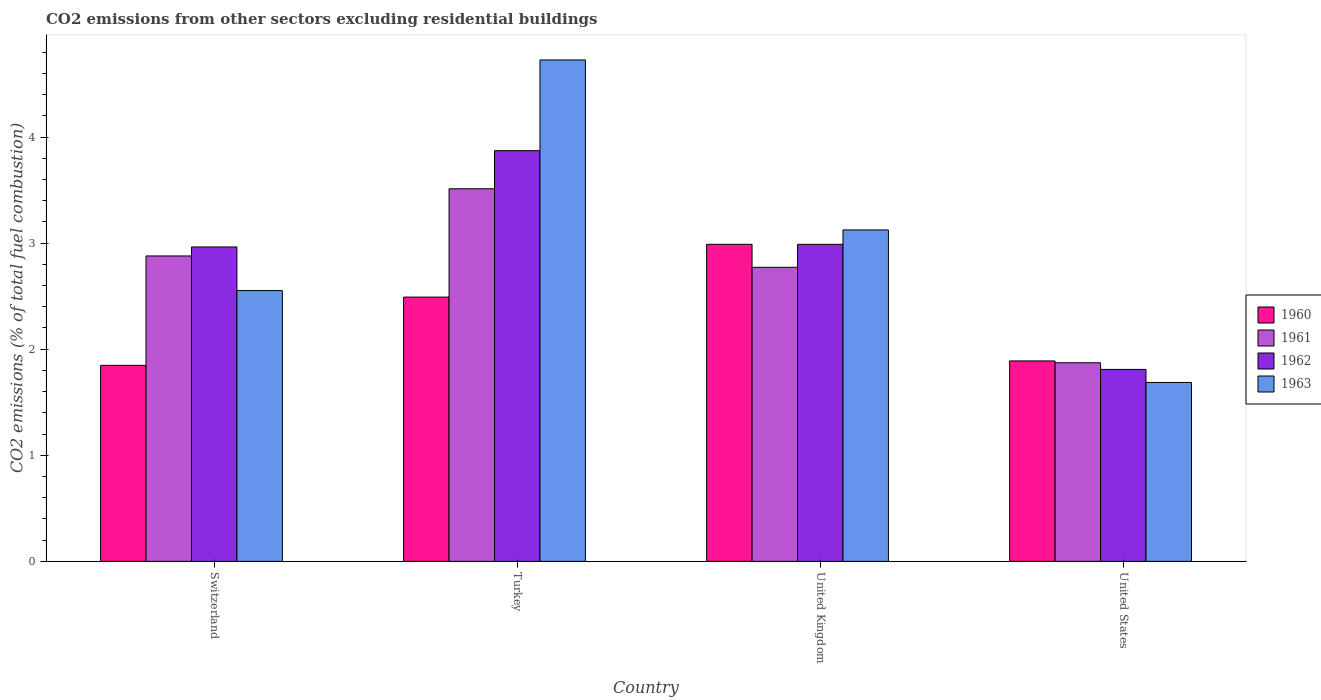How many different coloured bars are there?
Your response must be concise. 4. Are the number of bars on each tick of the X-axis equal?
Offer a very short reply. Yes. How many bars are there on the 2nd tick from the left?
Your response must be concise. 4. What is the label of the 3rd group of bars from the left?
Give a very brief answer. United Kingdom. What is the total CO2 emitted in 1963 in Switzerland?
Offer a terse response. 2.55. Across all countries, what is the maximum total CO2 emitted in 1962?
Keep it short and to the point. 3.87. Across all countries, what is the minimum total CO2 emitted in 1961?
Your answer should be compact. 1.87. What is the total total CO2 emitted in 1960 in the graph?
Provide a succinct answer. 9.22. What is the difference between the total CO2 emitted in 1962 in Switzerland and that in Turkey?
Keep it short and to the point. -0.91. What is the difference between the total CO2 emitted in 1963 in Turkey and the total CO2 emitted in 1960 in Switzerland?
Keep it short and to the point. 2.88. What is the average total CO2 emitted in 1960 per country?
Provide a succinct answer. 2.3. What is the difference between the total CO2 emitted of/in 1960 and total CO2 emitted of/in 1962 in United Kingdom?
Offer a terse response. -1.3986663769838259e-5. In how many countries, is the total CO2 emitted in 1963 greater than 3?
Provide a short and direct response. 2. What is the ratio of the total CO2 emitted in 1960 in Turkey to that in United Kingdom?
Your response must be concise. 0.83. Is the total CO2 emitted in 1961 in United Kingdom less than that in United States?
Offer a very short reply. No. What is the difference between the highest and the second highest total CO2 emitted in 1963?
Your answer should be compact. -0.57. What is the difference between the highest and the lowest total CO2 emitted in 1961?
Your answer should be very brief. 1.64. In how many countries, is the total CO2 emitted in 1961 greater than the average total CO2 emitted in 1961 taken over all countries?
Provide a short and direct response. 3. Is the sum of the total CO2 emitted in 1963 in Switzerland and United States greater than the maximum total CO2 emitted in 1960 across all countries?
Your answer should be compact. Yes. What does the 1st bar from the right in United States represents?
Your answer should be very brief. 1963. How many bars are there?
Provide a succinct answer. 16. Are all the bars in the graph horizontal?
Provide a succinct answer. No. Does the graph contain any zero values?
Provide a short and direct response. No. Does the graph contain grids?
Keep it short and to the point. No. How many legend labels are there?
Keep it short and to the point. 4. How are the legend labels stacked?
Your response must be concise. Vertical. What is the title of the graph?
Provide a succinct answer. CO2 emissions from other sectors excluding residential buildings. Does "1990" appear as one of the legend labels in the graph?
Your answer should be compact. No. What is the label or title of the Y-axis?
Offer a very short reply. CO2 emissions (% of total fuel combustion). What is the CO2 emissions (% of total fuel combustion) of 1960 in Switzerland?
Ensure brevity in your answer.  1.85. What is the CO2 emissions (% of total fuel combustion) in 1961 in Switzerland?
Offer a terse response. 2.88. What is the CO2 emissions (% of total fuel combustion) in 1962 in Switzerland?
Your response must be concise. 2.96. What is the CO2 emissions (% of total fuel combustion) in 1963 in Switzerland?
Your response must be concise. 2.55. What is the CO2 emissions (% of total fuel combustion) of 1960 in Turkey?
Give a very brief answer. 2.49. What is the CO2 emissions (% of total fuel combustion) of 1961 in Turkey?
Provide a short and direct response. 3.51. What is the CO2 emissions (% of total fuel combustion) of 1962 in Turkey?
Give a very brief answer. 3.87. What is the CO2 emissions (% of total fuel combustion) of 1963 in Turkey?
Keep it short and to the point. 4.73. What is the CO2 emissions (% of total fuel combustion) of 1960 in United Kingdom?
Keep it short and to the point. 2.99. What is the CO2 emissions (% of total fuel combustion) of 1961 in United Kingdom?
Offer a very short reply. 2.77. What is the CO2 emissions (% of total fuel combustion) of 1962 in United Kingdom?
Give a very brief answer. 2.99. What is the CO2 emissions (% of total fuel combustion) of 1963 in United Kingdom?
Make the answer very short. 3.12. What is the CO2 emissions (% of total fuel combustion) of 1960 in United States?
Provide a short and direct response. 1.89. What is the CO2 emissions (% of total fuel combustion) in 1961 in United States?
Your response must be concise. 1.87. What is the CO2 emissions (% of total fuel combustion) in 1962 in United States?
Your answer should be compact. 1.81. What is the CO2 emissions (% of total fuel combustion) in 1963 in United States?
Your response must be concise. 1.69. Across all countries, what is the maximum CO2 emissions (% of total fuel combustion) of 1960?
Give a very brief answer. 2.99. Across all countries, what is the maximum CO2 emissions (% of total fuel combustion) of 1961?
Offer a very short reply. 3.51. Across all countries, what is the maximum CO2 emissions (% of total fuel combustion) of 1962?
Your response must be concise. 3.87. Across all countries, what is the maximum CO2 emissions (% of total fuel combustion) in 1963?
Your answer should be very brief. 4.73. Across all countries, what is the minimum CO2 emissions (% of total fuel combustion) in 1960?
Provide a succinct answer. 1.85. Across all countries, what is the minimum CO2 emissions (% of total fuel combustion) in 1961?
Keep it short and to the point. 1.87. Across all countries, what is the minimum CO2 emissions (% of total fuel combustion) of 1962?
Make the answer very short. 1.81. Across all countries, what is the minimum CO2 emissions (% of total fuel combustion) in 1963?
Provide a succinct answer. 1.69. What is the total CO2 emissions (% of total fuel combustion) of 1960 in the graph?
Give a very brief answer. 9.22. What is the total CO2 emissions (% of total fuel combustion) in 1961 in the graph?
Make the answer very short. 11.03. What is the total CO2 emissions (% of total fuel combustion) of 1962 in the graph?
Your response must be concise. 11.63. What is the total CO2 emissions (% of total fuel combustion) in 1963 in the graph?
Your answer should be compact. 12.09. What is the difference between the CO2 emissions (% of total fuel combustion) in 1960 in Switzerland and that in Turkey?
Your answer should be compact. -0.64. What is the difference between the CO2 emissions (% of total fuel combustion) of 1961 in Switzerland and that in Turkey?
Provide a succinct answer. -0.63. What is the difference between the CO2 emissions (% of total fuel combustion) in 1962 in Switzerland and that in Turkey?
Offer a very short reply. -0.91. What is the difference between the CO2 emissions (% of total fuel combustion) in 1963 in Switzerland and that in Turkey?
Your answer should be compact. -2.17. What is the difference between the CO2 emissions (% of total fuel combustion) in 1960 in Switzerland and that in United Kingdom?
Your answer should be compact. -1.14. What is the difference between the CO2 emissions (% of total fuel combustion) of 1961 in Switzerland and that in United Kingdom?
Make the answer very short. 0.11. What is the difference between the CO2 emissions (% of total fuel combustion) of 1962 in Switzerland and that in United Kingdom?
Your answer should be compact. -0.02. What is the difference between the CO2 emissions (% of total fuel combustion) in 1963 in Switzerland and that in United Kingdom?
Provide a short and direct response. -0.57. What is the difference between the CO2 emissions (% of total fuel combustion) of 1960 in Switzerland and that in United States?
Offer a terse response. -0.04. What is the difference between the CO2 emissions (% of total fuel combustion) of 1961 in Switzerland and that in United States?
Give a very brief answer. 1.01. What is the difference between the CO2 emissions (% of total fuel combustion) of 1962 in Switzerland and that in United States?
Your answer should be compact. 1.15. What is the difference between the CO2 emissions (% of total fuel combustion) in 1963 in Switzerland and that in United States?
Your response must be concise. 0.87. What is the difference between the CO2 emissions (% of total fuel combustion) of 1960 in Turkey and that in United Kingdom?
Offer a terse response. -0.5. What is the difference between the CO2 emissions (% of total fuel combustion) in 1961 in Turkey and that in United Kingdom?
Provide a succinct answer. 0.74. What is the difference between the CO2 emissions (% of total fuel combustion) of 1962 in Turkey and that in United Kingdom?
Provide a short and direct response. 0.88. What is the difference between the CO2 emissions (% of total fuel combustion) of 1963 in Turkey and that in United Kingdom?
Your answer should be very brief. 1.6. What is the difference between the CO2 emissions (% of total fuel combustion) in 1960 in Turkey and that in United States?
Ensure brevity in your answer.  0.6. What is the difference between the CO2 emissions (% of total fuel combustion) in 1961 in Turkey and that in United States?
Provide a succinct answer. 1.64. What is the difference between the CO2 emissions (% of total fuel combustion) of 1962 in Turkey and that in United States?
Offer a very short reply. 2.06. What is the difference between the CO2 emissions (% of total fuel combustion) in 1963 in Turkey and that in United States?
Give a very brief answer. 3.04. What is the difference between the CO2 emissions (% of total fuel combustion) of 1960 in United Kingdom and that in United States?
Keep it short and to the point. 1.1. What is the difference between the CO2 emissions (% of total fuel combustion) in 1961 in United Kingdom and that in United States?
Ensure brevity in your answer.  0.9. What is the difference between the CO2 emissions (% of total fuel combustion) in 1962 in United Kingdom and that in United States?
Provide a short and direct response. 1.18. What is the difference between the CO2 emissions (% of total fuel combustion) of 1963 in United Kingdom and that in United States?
Offer a very short reply. 1.44. What is the difference between the CO2 emissions (% of total fuel combustion) in 1960 in Switzerland and the CO2 emissions (% of total fuel combustion) in 1961 in Turkey?
Offer a terse response. -1.66. What is the difference between the CO2 emissions (% of total fuel combustion) in 1960 in Switzerland and the CO2 emissions (% of total fuel combustion) in 1962 in Turkey?
Offer a terse response. -2.02. What is the difference between the CO2 emissions (% of total fuel combustion) of 1960 in Switzerland and the CO2 emissions (% of total fuel combustion) of 1963 in Turkey?
Offer a terse response. -2.88. What is the difference between the CO2 emissions (% of total fuel combustion) in 1961 in Switzerland and the CO2 emissions (% of total fuel combustion) in 1962 in Turkey?
Give a very brief answer. -0.99. What is the difference between the CO2 emissions (% of total fuel combustion) of 1961 in Switzerland and the CO2 emissions (% of total fuel combustion) of 1963 in Turkey?
Your response must be concise. -1.85. What is the difference between the CO2 emissions (% of total fuel combustion) of 1962 in Switzerland and the CO2 emissions (% of total fuel combustion) of 1963 in Turkey?
Give a very brief answer. -1.76. What is the difference between the CO2 emissions (% of total fuel combustion) of 1960 in Switzerland and the CO2 emissions (% of total fuel combustion) of 1961 in United Kingdom?
Ensure brevity in your answer.  -0.92. What is the difference between the CO2 emissions (% of total fuel combustion) of 1960 in Switzerland and the CO2 emissions (% of total fuel combustion) of 1962 in United Kingdom?
Provide a short and direct response. -1.14. What is the difference between the CO2 emissions (% of total fuel combustion) in 1960 in Switzerland and the CO2 emissions (% of total fuel combustion) in 1963 in United Kingdom?
Offer a very short reply. -1.28. What is the difference between the CO2 emissions (% of total fuel combustion) of 1961 in Switzerland and the CO2 emissions (% of total fuel combustion) of 1962 in United Kingdom?
Give a very brief answer. -0.11. What is the difference between the CO2 emissions (% of total fuel combustion) of 1961 in Switzerland and the CO2 emissions (% of total fuel combustion) of 1963 in United Kingdom?
Your answer should be compact. -0.25. What is the difference between the CO2 emissions (% of total fuel combustion) of 1962 in Switzerland and the CO2 emissions (% of total fuel combustion) of 1963 in United Kingdom?
Keep it short and to the point. -0.16. What is the difference between the CO2 emissions (% of total fuel combustion) of 1960 in Switzerland and the CO2 emissions (% of total fuel combustion) of 1961 in United States?
Ensure brevity in your answer.  -0.02. What is the difference between the CO2 emissions (% of total fuel combustion) of 1960 in Switzerland and the CO2 emissions (% of total fuel combustion) of 1962 in United States?
Your response must be concise. 0.04. What is the difference between the CO2 emissions (% of total fuel combustion) in 1960 in Switzerland and the CO2 emissions (% of total fuel combustion) in 1963 in United States?
Your answer should be compact. 0.16. What is the difference between the CO2 emissions (% of total fuel combustion) in 1961 in Switzerland and the CO2 emissions (% of total fuel combustion) in 1962 in United States?
Ensure brevity in your answer.  1.07. What is the difference between the CO2 emissions (% of total fuel combustion) in 1961 in Switzerland and the CO2 emissions (% of total fuel combustion) in 1963 in United States?
Your answer should be very brief. 1.19. What is the difference between the CO2 emissions (% of total fuel combustion) in 1962 in Switzerland and the CO2 emissions (% of total fuel combustion) in 1963 in United States?
Your answer should be very brief. 1.28. What is the difference between the CO2 emissions (% of total fuel combustion) in 1960 in Turkey and the CO2 emissions (% of total fuel combustion) in 1961 in United Kingdom?
Offer a terse response. -0.28. What is the difference between the CO2 emissions (% of total fuel combustion) in 1960 in Turkey and the CO2 emissions (% of total fuel combustion) in 1962 in United Kingdom?
Your answer should be compact. -0.5. What is the difference between the CO2 emissions (% of total fuel combustion) in 1960 in Turkey and the CO2 emissions (% of total fuel combustion) in 1963 in United Kingdom?
Provide a succinct answer. -0.63. What is the difference between the CO2 emissions (% of total fuel combustion) of 1961 in Turkey and the CO2 emissions (% of total fuel combustion) of 1962 in United Kingdom?
Ensure brevity in your answer.  0.52. What is the difference between the CO2 emissions (% of total fuel combustion) in 1961 in Turkey and the CO2 emissions (% of total fuel combustion) in 1963 in United Kingdom?
Ensure brevity in your answer.  0.39. What is the difference between the CO2 emissions (% of total fuel combustion) in 1962 in Turkey and the CO2 emissions (% of total fuel combustion) in 1963 in United Kingdom?
Your answer should be very brief. 0.75. What is the difference between the CO2 emissions (% of total fuel combustion) of 1960 in Turkey and the CO2 emissions (% of total fuel combustion) of 1961 in United States?
Ensure brevity in your answer.  0.62. What is the difference between the CO2 emissions (% of total fuel combustion) in 1960 in Turkey and the CO2 emissions (% of total fuel combustion) in 1962 in United States?
Keep it short and to the point. 0.68. What is the difference between the CO2 emissions (% of total fuel combustion) of 1960 in Turkey and the CO2 emissions (% of total fuel combustion) of 1963 in United States?
Keep it short and to the point. 0.8. What is the difference between the CO2 emissions (% of total fuel combustion) of 1961 in Turkey and the CO2 emissions (% of total fuel combustion) of 1962 in United States?
Your answer should be very brief. 1.7. What is the difference between the CO2 emissions (% of total fuel combustion) in 1961 in Turkey and the CO2 emissions (% of total fuel combustion) in 1963 in United States?
Your response must be concise. 1.83. What is the difference between the CO2 emissions (% of total fuel combustion) of 1962 in Turkey and the CO2 emissions (% of total fuel combustion) of 1963 in United States?
Give a very brief answer. 2.18. What is the difference between the CO2 emissions (% of total fuel combustion) of 1960 in United Kingdom and the CO2 emissions (% of total fuel combustion) of 1961 in United States?
Make the answer very short. 1.12. What is the difference between the CO2 emissions (% of total fuel combustion) in 1960 in United Kingdom and the CO2 emissions (% of total fuel combustion) in 1962 in United States?
Ensure brevity in your answer.  1.18. What is the difference between the CO2 emissions (% of total fuel combustion) in 1960 in United Kingdom and the CO2 emissions (% of total fuel combustion) in 1963 in United States?
Give a very brief answer. 1.3. What is the difference between the CO2 emissions (% of total fuel combustion) in 1961 in United Kingdom and the CO2 emissions (% of total fuel combustion) in 1962 in United States?
Keep it short and to the point. 0.96. What is the difference between the CO2 emissions (% of total fuel combustion) of 1961 in United Kingdom and the CO2 emissions (% of total fuel combustion) of 1963 in United States?
Provide a short and direct response. 1.09. What is the difference between the CO2 emissions (% of total fuel combustion) in 1962 in United Kingdom and the CO2 emissions (% of total fuel combustion) in 1963 in United States?
Make the answer very short. 1.3. What is the average CO2 emissions (% of total fuel combustion) of 1960 per country?
Keep it short and to the point. 2.3. What is the average CO2 emissions (% of total fuel combustion) of 1961 per country?
Offer a very short reply. 2.76. What is the average CO2 emissions (% of total fuel combustion) of 1962 per country?
Offer a terse response. 2.91. What is the average CO2 emissions (% of total fuel combustion) in 1963 per country?
Your answer should be very brief. 3.02. What is the difference between the CO2 emissions (% of total fuel combustion) of 1960 and CO2 emissions (% of total fuel combustion) of 1961 in Switzerland?
Offer a very short reply. -1.03. What is the difference between the CO2 emissions (% of total fuel combustion) in 1960 and CO2 emissions (% of total fuel combustion) in 1962 in Switzerland?
Your response must be concise. -1.12. What is the difference between the CO2 emissions (% of total fuel combustion) in 1960 and CO2 emissions (% of total fuel combustion) in 1963 in Switzerland?
Offer a terse response. -0.7. What is the difference between the CO2 emissions (% of total fuel combustion) in 1961 and CO2 emissions (% of total fuel combustion) in 1962 in Switzerland?
Your answer should be compact. -0.08. What is the difference between the CO2 emissions (% of total fuel combustion) of 1961 and CO2 emissions (% of total fuel combustion) of 1963 in Switzerland?
Offer a very short reply. 0.33. What is the difference between the CO2 emissions (% of total fuel combustion) in 1962 and CO2 emissions (% of total fuel combustion) in 1963 in Switzerland?
Your response must be concise. 0.41. What is the difference between the CO2 emissions (% of total fuel combustion) in 1960 and CO2 emissions (% of total fuel combustion) in 1961 in Turkey?
Offer a terse response. -1.02. What is the difference between the CO2 emissions (% of total fuel combustion) of 1960 and CO2 emissions (% of total fuel combustion) of 1962 in Turkey?
Keep it short and to the point. -1.38. What is the difference between the CO2 emissions (% of total fuel combustion) in 1960 and CO2 emissions (% of total fuel combustion) in 1963 in Turkey?
Ensure brevity in your answer.  -2.24. What is the difference between the CO2 emissions (% of total fuel combustion) of 1961 and CO2 emissions (% of total fuel combustion) of 1962 in Turkey?
Ensure brevity in your answer.  -0.36. What is the difference between the CO2 emissions (% of total fuel combustion) in 1961 and CO2 emissions (% of total fuel combustion) in 1963 in Turkey?
Provide a succinct answer. -1.21. What is the difference between the CO2 emissions (% of total fuel combustion) of 1962 and CO2 emissions (% of total fuel combustion) of 1963 in Turkey?
Offer a terse response. -0.85. What is the difference between the CO2 emissions (% of total fuel combustion) in 1960 and CO2 emissions (% of total fuel combustion) in 1961 in United Kingdom?
Your answer should be very brief. 0.22. What is the difference between the CO2 emissions (% of total fuel combustion) in 1960 and CO2 emissions (% of total fuel combustion) in 1963 in United Kingdom?
Offer a terse response. -0.14. What is the difference between the CO2 emissions (% of total fuel combustion) of 1961 and CO2 emissions (% of total fuel combustion) of 1962 in United Kingdom?
Offer a very short reply. -0.22. What is the difference between the CO2 emissions (% of total fuel combustion) in 1961 and CO2 emissions (% of total fuel combustion) in 1963 in United Kingdom?
Ensure brevity in your answer.  -0.35. What is the difference between the CO2 emissions (% of total fuel combustion) of 1962 and CO2 emissions (% of total fuel combustion) of 1963 in United Kingdom?
Offer a very short reply. -0.14. What is the difference between the CO2 emissions (% of total fuel combustion) in 1960 and CO2 emissions (% of total fuel combustion) in 1961 in United States?
Offer a terse response. 0.02. What is the difference between the CO2 emissions (% of total fuel combustion) of 1960 and CO2 emissions (% of total fuel combustion) of 1962 in United States?
Your response must be concise. 0.08. What is the difference between the CO2 emissions (% of total fuel combustion) of 1960 and CO2 emissions (% of total fuel combustion) of 1963 in United States?
Offer a very short reply. 0.2. What is the difference between the CO2 emissions (% of total fuel combustion) in 1961 and CO2 emissions (% of total fuel combustion) in 1962 in United States?
Your answer should be compact. 0.06. What is the difference between the CO2 emissions (% of total fuel combustion) in 1961 and CO2 emissions (% of total fuel combustion) in 1963 in United States?
Offer a terse response. 0.19. What is the difference between the CO2 emissions (% of total fuel combustion) of 1962 and CO2 emissions (% of total fuel combustion) of 1963 in United States?
Offer a terse response. 0.12. What is the ratio of the CO2 emissions (% of total fuel combustion) in 1960 in Switzerland to that in Turkey?
Make the answer very short. 0.74. What is the ratio of the CO2 emissions (% of total fuel combustion) in 1961 in Switzerland to that in Turkey?
Your response must be concise. 0.82. What is the ratio of the CO2 emissions (% of total fuel combustion) in 1962 in Switzerland to that in Turkey?
Give a very brief answer. 0.77. What is the ratio of the CO2 emissions (% of total fuel combustion) of 1963 in Switzerland to that in Turkey?
Ensure brevity in your answer.  0.54. What is the ratio of the CO2 emissions (% of total fuel combustion) in 1960 in Switzerland to that in United Kingdom?
Your response must be concise. 0.62. What is the ratio of the CO2 emissions (% of total fuel combustion) of 1961 in Switzerland to that in United Kingdom?
Your response must be concise. 1.04. What is the ratio of the CO2 emissions (% of total fuel combustion) of 1963 in Switzerland to that in United Kingdom?
Keep it short and to the point. 0.82. What is the ratio of the CO2 emissions (% of total fuel combustion) of 1961 in Switzerland to that in United States?
Provide a short and direct response. 1.54. What is the ratio of the CO2 emissions (% of total fuel combustion) of 1962 in Switzerland to that in United States?
Provide a succinct answer. 1.64. What is the ratio of the CO2 emissions (% of total fuel combustion) of 1963 in Switzerland to that in United States?
Offer a terse response. 1.51. What is the ratio of the CO2 emissions (% of total fuel combustion) in 1960 in Turkey to that in United Kingdom?
Offer a terse response. 0.83. What is the ratio of the CO2 emissions (% of total fuel combustion) in 1961 in Turkey to that in United Kingdom?
Ensure brevity in your answer.  1.27. What is the ratio of the CO2 emissions (% of total fuel combustion) of 1962 in Turkey to that in United Kingdom?
Provide a short and direct response. 1.3. What is the ratio of the CO2 emissions (% of total fuel combustion) in 1963 in Turkey to that in United Kingdom?
Offer a terse response. 1.51. What is the ratio of the CO2 emissions (% of total fuel combustion) of 1960 in Turkey to that in United States?
Offer a very short reply. 1.32. What is the ratio of the CO2 emissions (% of total fuel combustion) in 1961 in Turkey to that in United States?
Your response must be concise. 1.88. What is the ratio of the CO2 emissions (% of total fuel combustion) in 1962 in Turkey to that in United States?
Keep it short and to the point. 2.14. What is the ratio of the CO2 emissions (% of total fuel combustion) in 1963 in Turkey to that in United States?
Your answer should be compact. 2.8. What is the ratio of the CO2 emissions (% of total fuel combustion) of 1960 in United Kingdom to that in United States?
Provide a succinct answer. 1.58. What is the ratio of the CO2 emissions (% of total fuel combustion) in 1961 in United Kingdom to that in United States?
Offer a very short reply. 1.48. What is the ratio of the CO2 emissions (% of total fuel combustion) in 1962 in United Kingdom to that in United States?
Your answer should be compact. 1.65. What is the ratio of the CO2 emissions (% of total fuel combustion) of 1963 in United Kingdom to that in United States?
Your answer should be very brief. 1.85. What is the difference between the highest and the second highest CO2 emissions (% of total fuel combustion) of 1960?
Offer a very short reply. 0.5. What is the difference between the highest and the second highest CO2 emissions (% of total fuel combustion) in 1961?
Ensure brevity in your answer.  0.63. What is the difference between the highest and the second highest CO2 emissions (% of total fuel combustion) in 1962?
Keep it short and to the point. 0.88. What is the difference between the highest and the second highest CO2 emissions (% of total fuel combustion) in 1963?
Provide a short and direct response. 1.6. What is the difference between the highest and the lowest CO2 emissions (% of total fuel combustion) of 1960?
Ensure brevity in your answer.  1.14. What is the difference between the highest and the lowest CO2 emissions (% of total fuel combustion) of 1961?
Your answer should be compact. 1.64. What is the difference between the highest and the lowest CO2 emissions (% of total fuel combustion) of 1962?
Provide a short and direct response. 2.06. What is the difference between the highest and the lowest CO2 emissions (% of total fuel combustion) in 1963?
Keep it short and to the point. 3.04. 